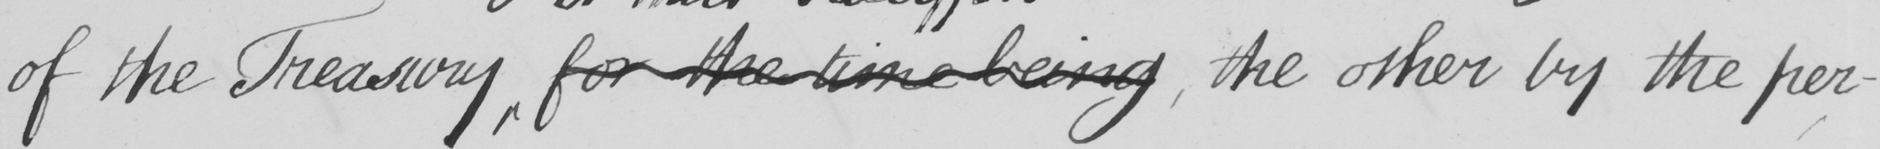What does this handwritten line say? of the Treasury for the time being , the other by the per- 